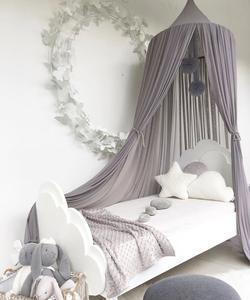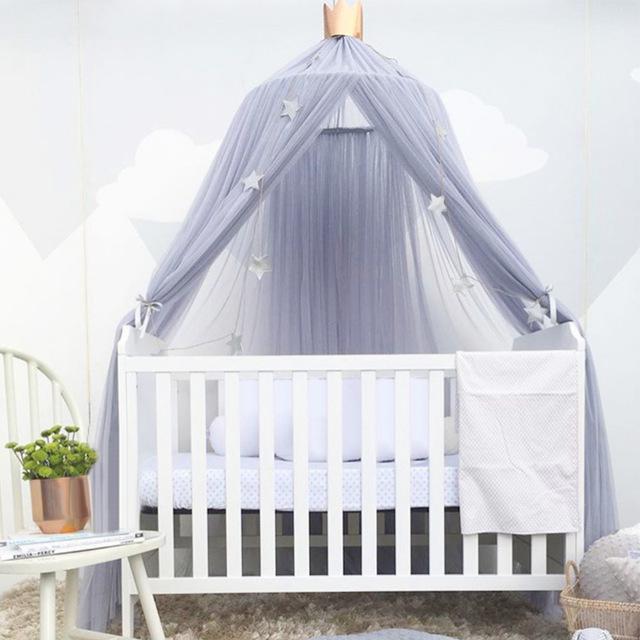The first image is the image on the left, the second image is the image on the right. Evaluate the accuracy of this statement regarding the images: "The right image shows a gauzy light gray canopy with a garland of stars hung from the ceiling over a toddler bed with vertical bars and a chair with a plant on its seat next to it.". Is it true? Answer yes or no. Yes. 